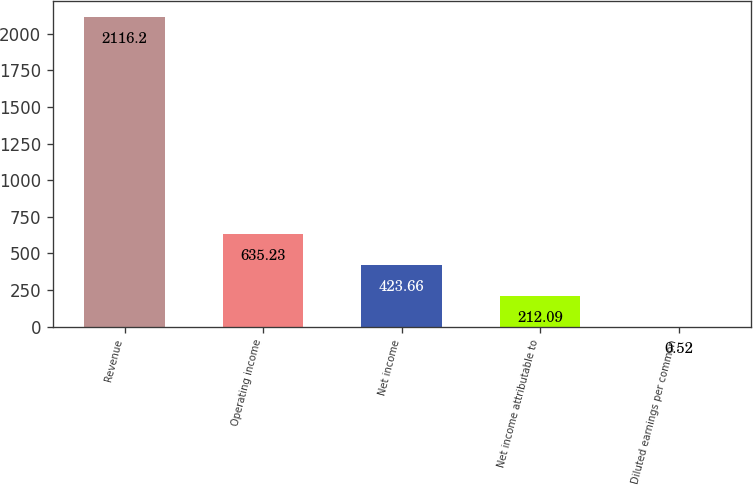Convert chart. <chart><loc_0><loc_0><loc_500><loc_500><bar_chart><fcel>Revenue<fcel>Operating income<fcel>Net income<fcel>Net income attributable to<fcel>Diluted earnings per common<nl><fcel>2116.2<fcel>635.23<fcel>423.66<fcel>212.09<fcel>0.52<nl></chart> 